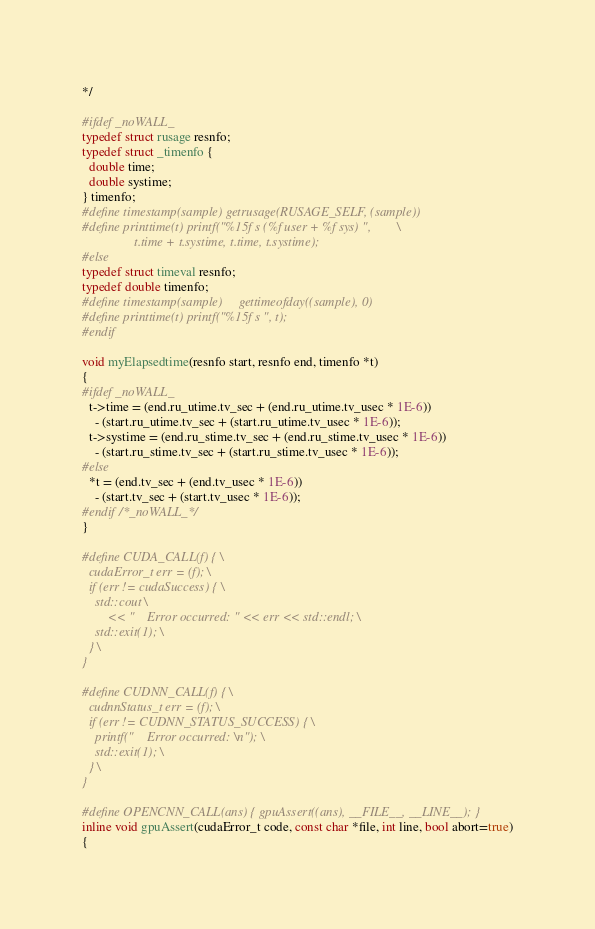Convert code to text. <code><loc_0><loc_0><loc_500><loc_500><_Cuda_>*/

#ifdef _noWALL_
typedef struct rusage resnfo;
typedef struct _timenfo {
  double time;
  double systime;
} timenfo;
#define timestamp(sample) getrusage(RUSAGE_SELF, (sample))
#define printtime(t) printf("%15f s (%f user + %f sys) ",		\
			    t.time + t.systime, t.time, t.systime);
#else
typedef struct timeval resnfo;
typedef double timenfo;
#define timestamp(sample)     gettimeofday((sample), 0)
#define printtime(t) printf("%15f s ", t);
#endif

void myElapsedtime(resnfo start, resnfo end, timenfo *t)
{
#ifdef _noWALL_
  t->time = (end.ru_utime.tv_sec + (end.ru_utime.tv_usec * 1E-6))
    - (start.ru_utime.tv_sec + (start.ru_utime.tv_usec * 1E-6));
  t->systime = (end.ru_stime.tv_sec + (end.ru_stime.tv_usec * 1E-6))
    - (start.ru_stime.tv_sec + (start.ru_stime.tv_usec * 1E-6));
#else
  *t = (end.tv_sec + (end.tv_usec * 1E-6))
    - (start.tv_sec + (start.tv_usec * 1E-6));
#endif /*_noWALL_*/
}

#define CUDA_CALL(f) { \
  cudaError_t err = (f); \
  if (err != cudaSuccess) { \
    std::cout \
        << "    Error occurred: " << err << std::endl; \
    std::exit(1); \
  } \
}

#define CUDNN_CALL(f) { \
  cudnnStatus_t err = (f); \
  if (err != CUDNN_STATUS_SUCCESS) { \
    printf("    Error occurred: \n"); \
    std::exit(1); \
  } \
}

#define OPENCNN_CALL(ans) { gpuAssert((ans), __FILE__, __LINE__); }
inline void gpuAssert(cudaError_t code, const char *file, int line, bool abort=true)
{</code> 